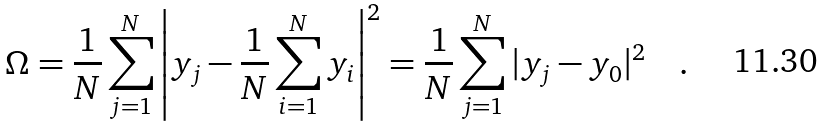Convert formula to latex. <formula><loc_0><loc_0><loc_500><loc_500>\Omega = \frac { 1 } { N } \sum ^ { N } _ { j = 1 } \left | { y } _ { j } - \frac { 1 } { N } \sum ^ { N } _ { i = 1 } { y } _ { i } \right | ^ { 2 } = \frac { 1 } { N } \sum ^ { N } _ { j = 1 } | { y } _ { j } - { y } _ { 0 } | ^ { 2 } \quad .</formula> 